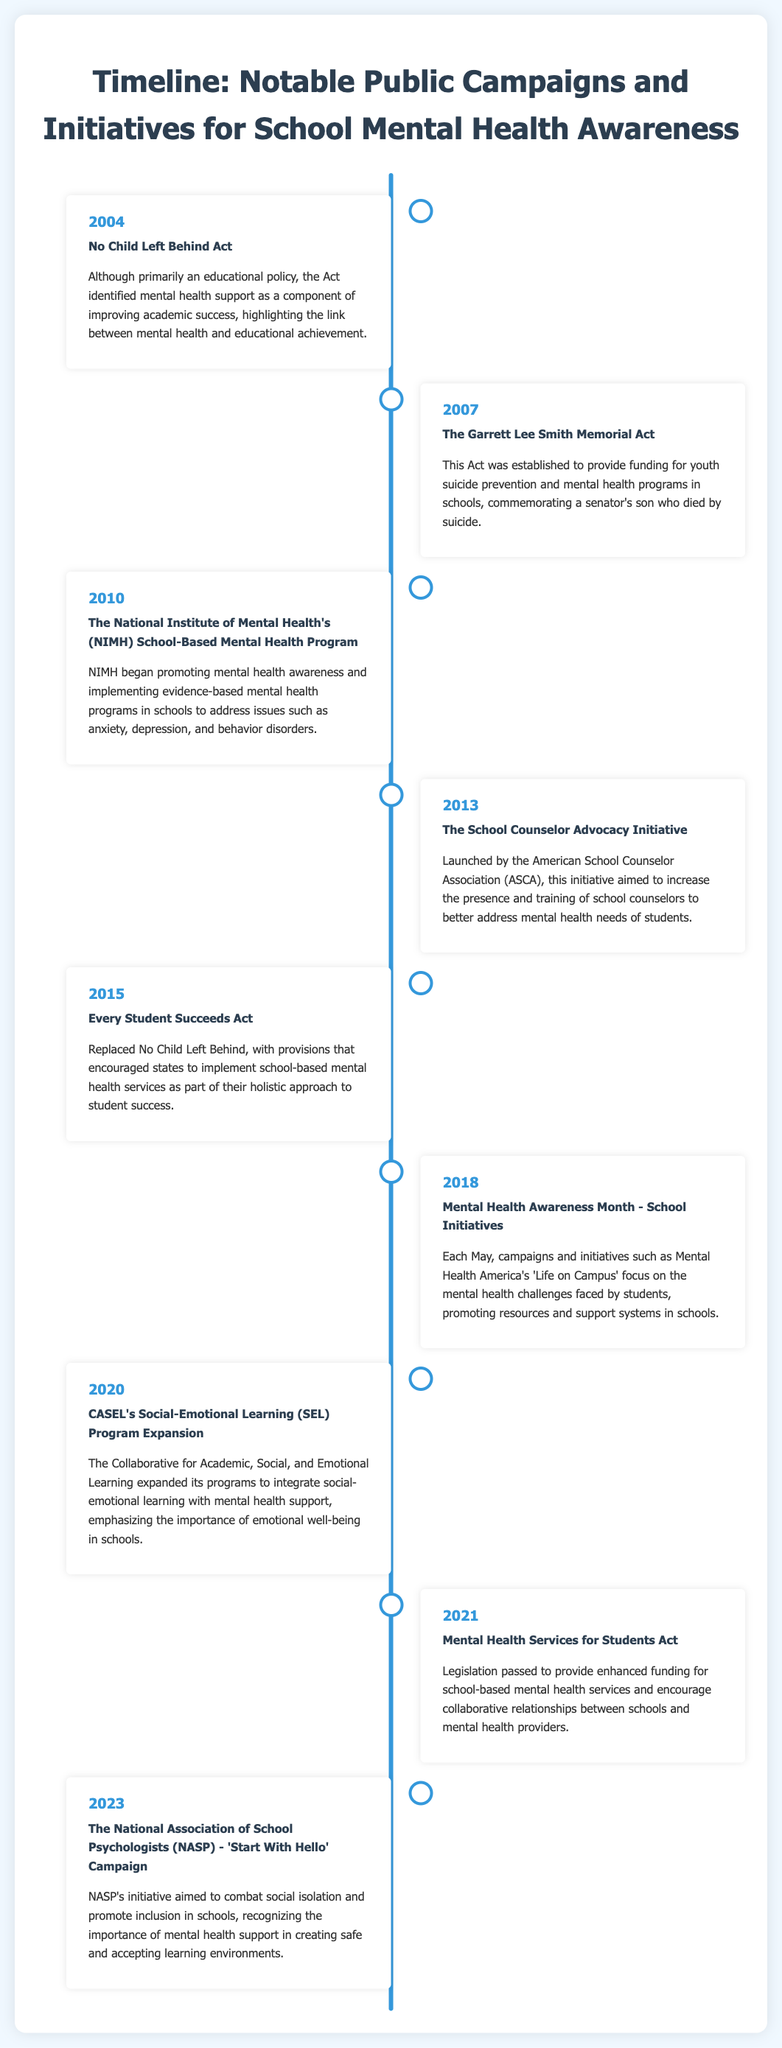What year was the No Child Left Behind Act enacted? The document states that the No Child Left Behind Act was enacted in 2004.
Answer: 2004 What initiative was established in 2013? According to the timeline, the School Counselor Advocacy Initiative was launched in 2013.
Answer: School Counselor Advocacy Initiative Which Act was introduced in 2021? The document mentions the Mental Health Services for Students Act was passed in 2021.
Answer: Mental Health Services for Students Act In which year did Mental Health Awareness Month initiatives for schools begin? The timeline indicates that in 2018, Mental Health Awareness Month initiatives specifically for schools started.
Answer: 2018 What is the name of the campaign launched by NASP in 2023? The document highlights the 'Start With Hello' Campaign initiated by NASP in 2023.
Answer: Start With Hello Which initiative was related to suicide prevention? The Garrett Lee Smith Memorial Act established funding for youth suicide prevention and mental health programs in schools.
Answer: The Garrett Lee Smith Memorial Act How many notable initiatives are listed in the document? The timeline includes 9 notable initiatives for school mental health awareness.
Answer: 9 What does CASEL stand for? The document mentions the Collaborative for Academic, Social, and Emotional Learning (CASEL) in reference to its SEL expansion in 2020.
Answer: Collaborative for Academic, Social, and Emotional Learning What common theme can be identified across the initiatives? A clear theme across the various initiatives is the integration of mental health support into educational settings.
Answer: Integration of mental health support 